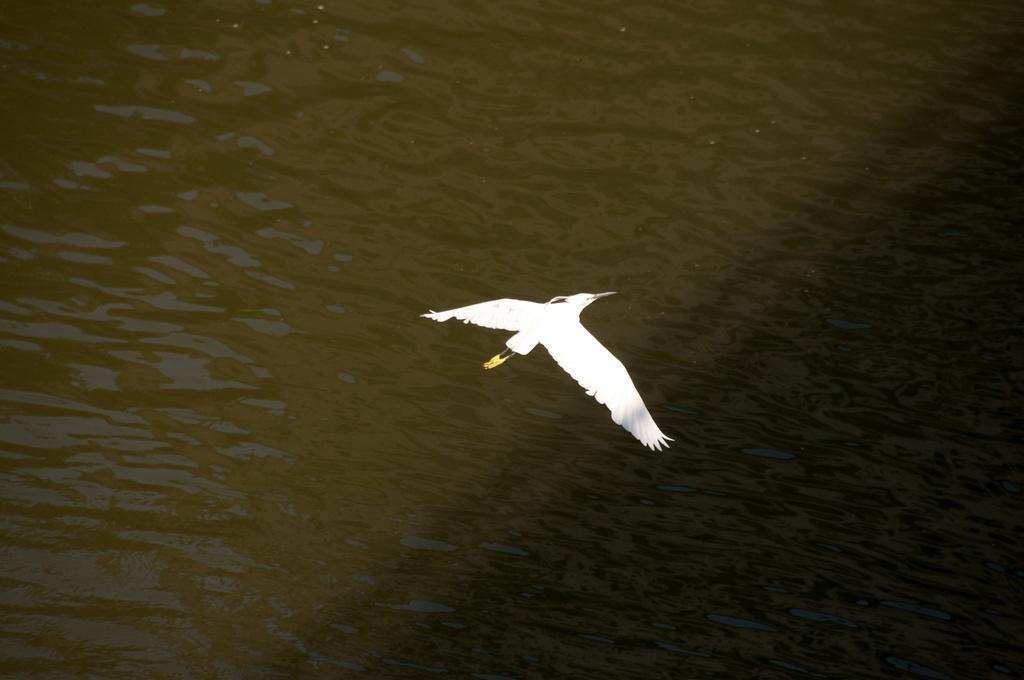What type of animal can be seen in the image? There is a bird in the image. What is the color of the bird? The bird is white in color. What is the bird doing in the image? The bird is flying. What natural element is visible in the image? There is water visible in the image. Where is the rake being used in the image? There is no rake present in the image. What type of feast is being prepared in the image? There is no feast being prepared in the image. 